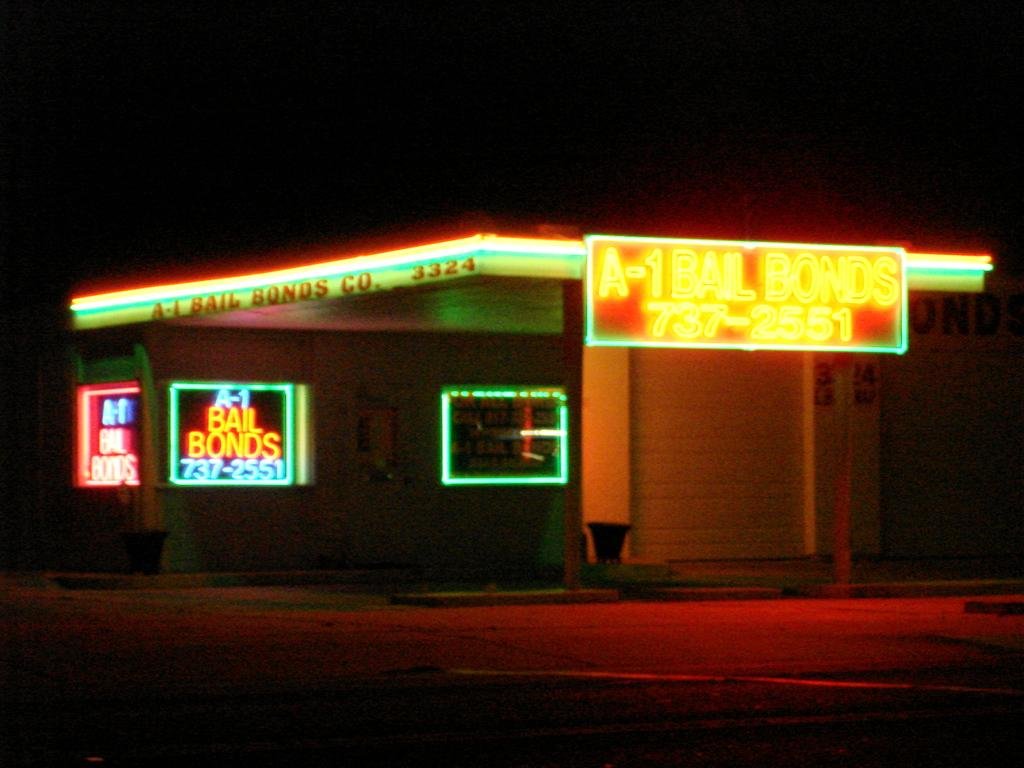What type of structure is present in the image? There is a house in the image. What natural phenomenon is visible on top of the house? Lightning is visible on top of the house. At what time of day was the image taken? The image was taken during the night. How many cows can be seen grazing near the coast in the image? There are no cows or coast visible in the image; it features a house with lightning on top during the night. 